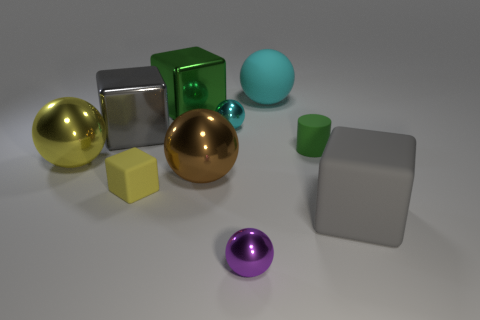What number of things are either tiny red cylinders or big blocks?
Give a very brief answer. 3. What is the material of the green cylinder that is the same size as the yellow cube?
Your response must be concise. Rubber. There is a green object that is to the left of the small rubber cylinder; what is its size?
Provide a short and direct response. Large. What material is the yellow ball?
Your response must be concise. Metal. What number of objects are small metallic spheres that are to the right of the cyan shiny sphere or metal objects that are to the left of the purple object?
Make the answer very short. 6. How many other things are the same color as the tiny rubber block?
Offer a terse response. 1. Is the shape of the small yellow matte thing the same as the large gray object left of the brown metal sphere?
Make the answer very short. Yes. Is the number of cyan metallic things to the right of the green matte cylinder less than the number of big gray objects that are in front of the tiny cyan object?
Your answer should be compact. Yes. What is the material of the other tiny thing that is the same shape as the purple shiny object?
Provide a short and direct response. Metal. Are there any other things that have the same material as the large yellow object?
Offer a very short reply. Yes. 